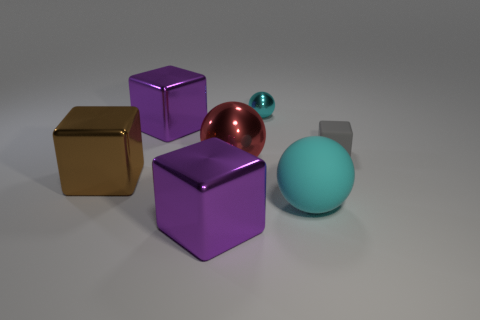There is a cyan sphere that is in front of the tiny matte cube; is it the same size as the thing on the right side of the rubber sphere?
Your answer should be very brief. No. Are there any big yellow metal things that have the same shape as the big cyan thing?
Offer a very short reply. No. Are there fewer big red metal balls on the left side of the large brown object than spheres?
Make the answer very short. Yes. Does the red thing have the same shape as the brown metallic thing?
Provide a short and direct response. No. What size is the metal thing that is on the right side of the red metal object?
Make the answer very short. Small. What is the size of the brown block that is the same material as the red object?
Provide a short and direct response. Large. Are there fewer tiny gray metal cubes than spheres?
Make the answer very short. Yes. There is a gray object that is the same size as the cyan shiny thing; what material is it?
Your response must be concise. Rubber. Are there more large matte spheres than large purple balls?
Your response must be concise. Yes. What number of other things are there of the same color as the rubber cube?
Give a very brief answer. 0. 